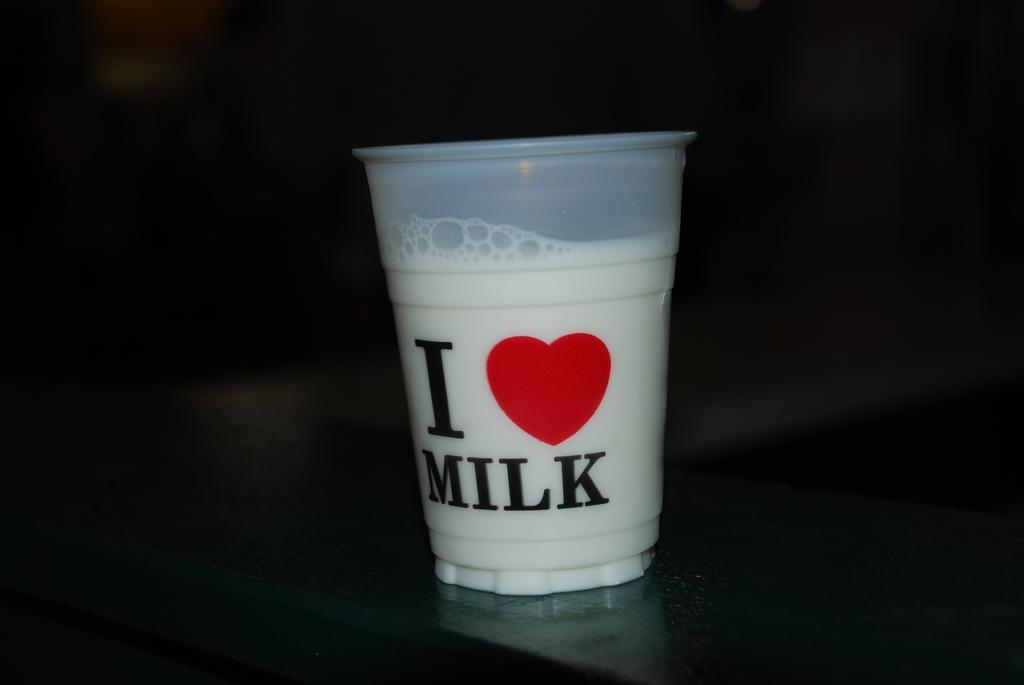<image>
Summarize the visual content of the image. A glass of milk that says I love milk on a dark table. 